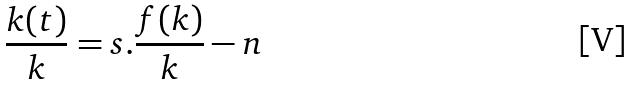Convert formula to latex. <formula><loc_0><loc_0><loc_500><loc_500>\frac { k ( t ) } { k } = s . \frac { f ( k ) } { k } - n</formula> 